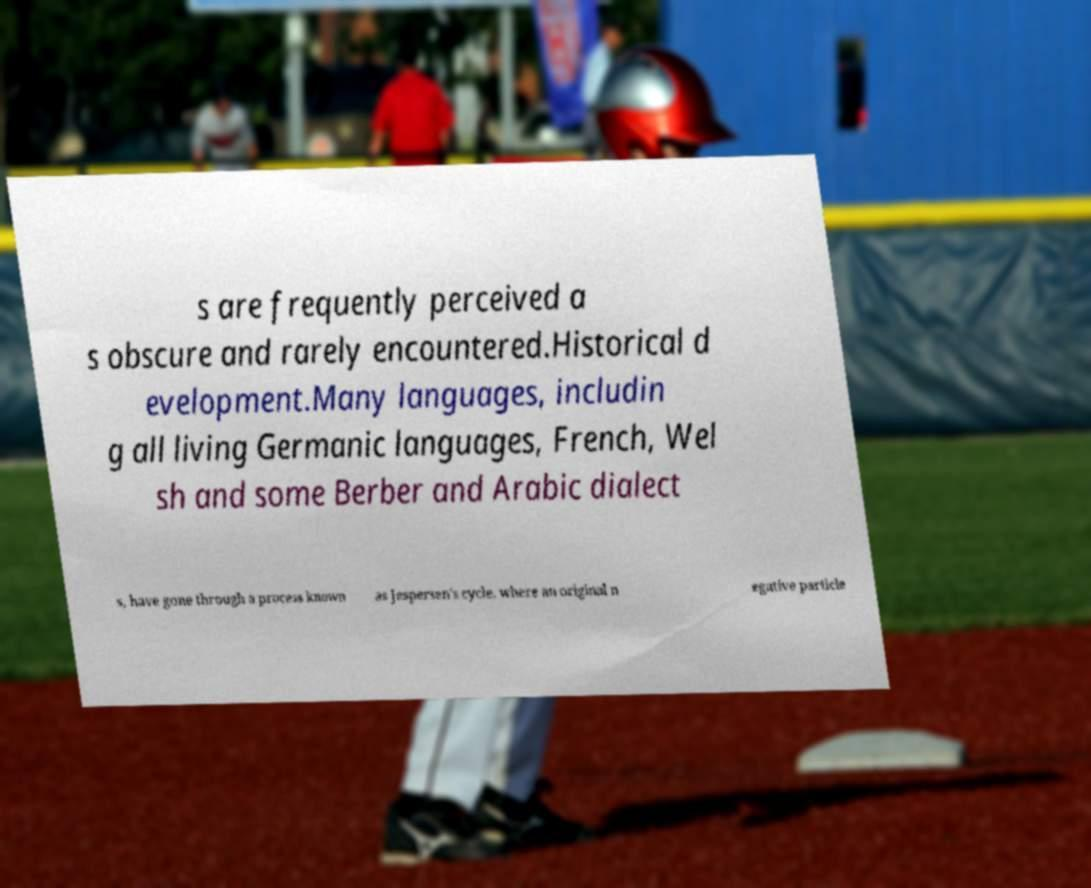I need the written content from this picture converted into text. Can you do that? s are frequently perceived a s obscure and rarely encountered.Historical d evelopment.Many languages, includin g all living Germanic languages, French, Wel sh and some Berber and Arabic dialect s, have gone through a process known as Jespersen's cycle, where an original n egative particle 